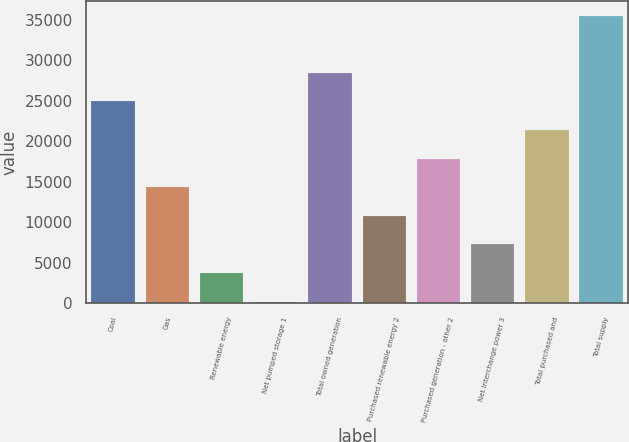Convert chart to OTSL. <chart><loc_0><loc_0><loc_500><loc_500><bar_chart><fcel>Coal<fcel>Gas<fcel>Renewable energy<fcel>Net pumped storage 1<fcel>Total owned generation<fcel>Purchased renewable energy 2<fcel>Purchased generation - other 2<fcel>Net interchange power 3<fcel>Total purchased and<fcel>Total supply<nl><fcel>24915.6<fcel>14317.2<fcel>3718.8<fcel>186<fcel>28448.4<fcel>10784.4<fcel>17850<fcel>7251.6<fcel>21382.8<fcel>35514<nl></chart> 